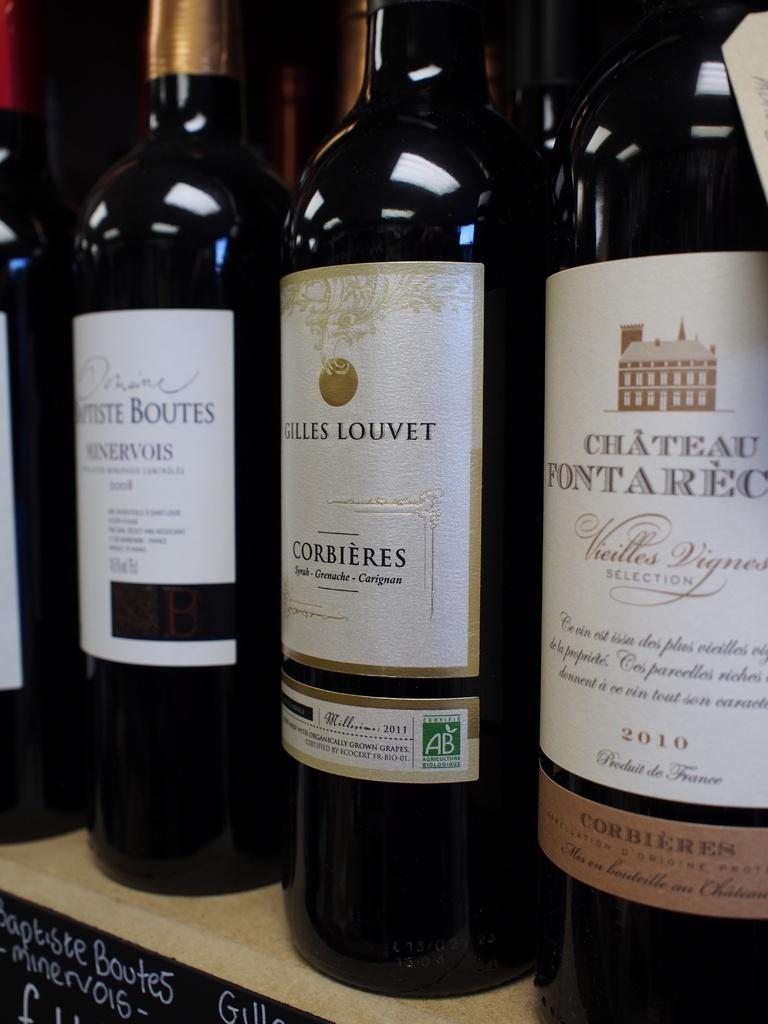<image>
Share a concise interpretation of the image provided. Bottles of wine, including Gilles Louvet, are lined up on a counter. 